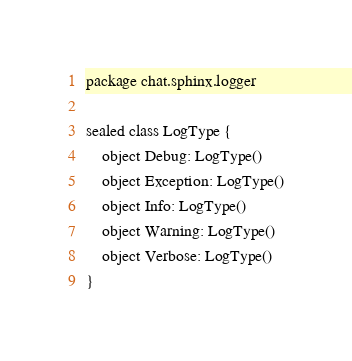<code> <loc_0><loc_0><loc_500><loc_500><_Kotlin_>package chat.sphinx.logger

sealed class LogType {
    object Debug: LogType()
    object Exception: LogType()
    object Info: LogType()
    object Warning: LogType()
    object Verbose: LogType()
}
</code> 